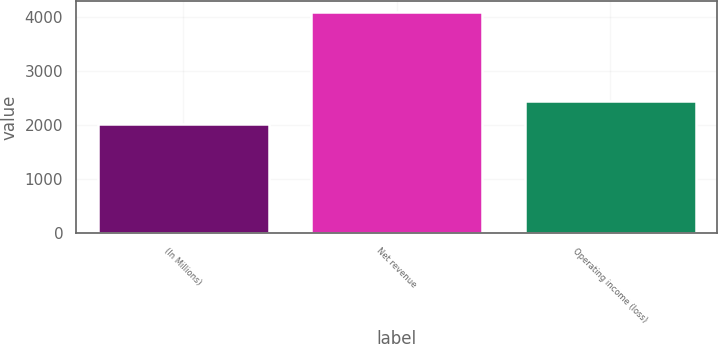<chart> <loc_0><loc_0><loc_500><loc_500><bar_chart><fcel>(In Millions)<fcel>Net revenue<fcel>Operating income (loss)<nl><fcel>2013<fcel>4092<fcel>2445<nl></chart> 